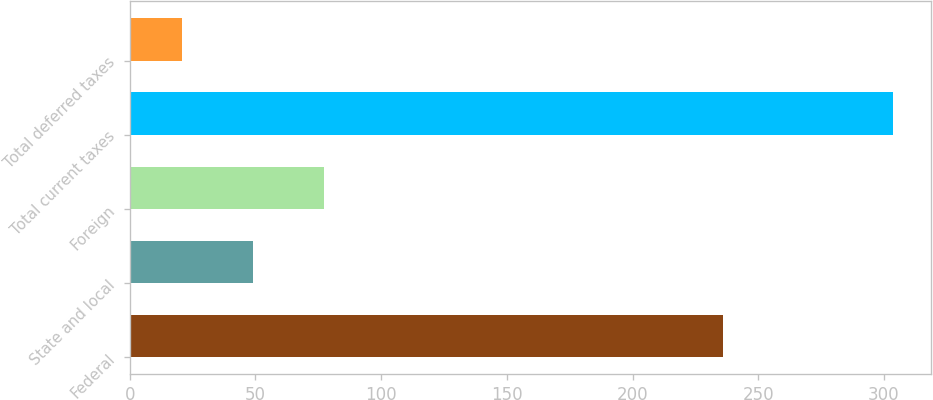Convert chart. <chart><loc_0><loc_0><loc_500><loc_500><bar_chart><fcel>Federal<fcel>State and local<fcel>Foreign<fcel>Total current taxes<fcel>Total deferred taxes<nl><fcel>235.8<fcel>49.17<fcel>77.44<fcel>303.6<fcel>20.9<nl></chart> 